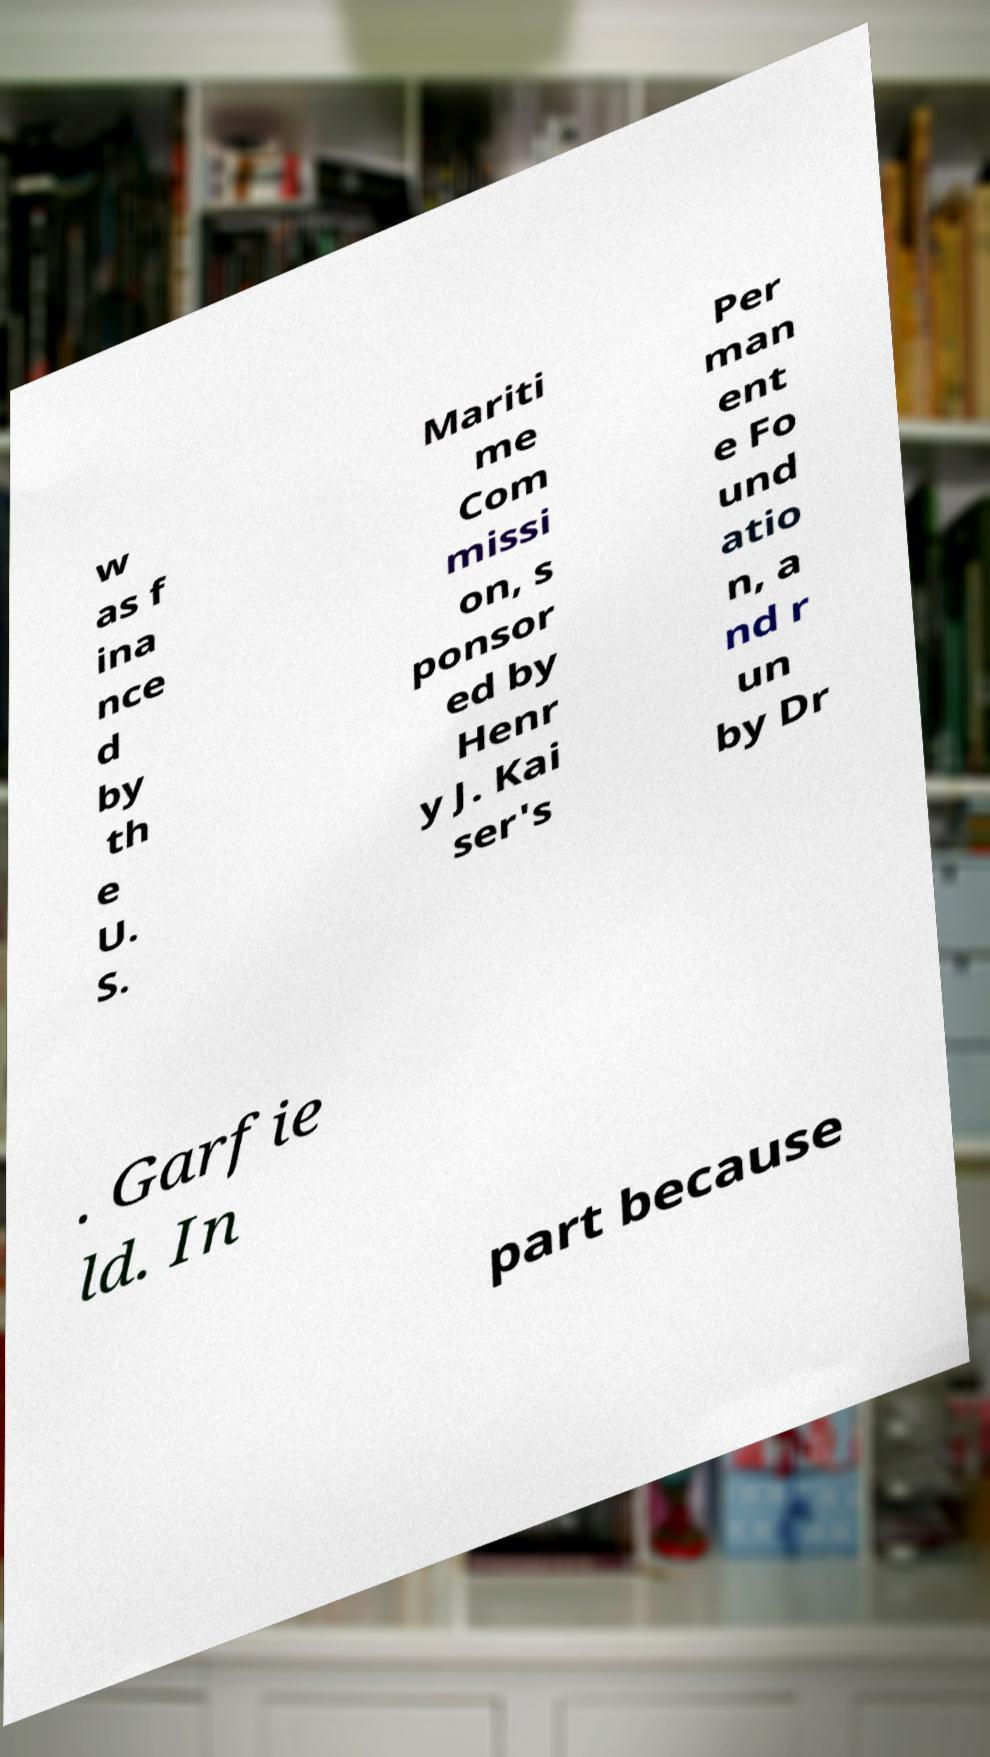Can you read and provide the text displayed in the image?This photo seems to have some interesting text. Can you extract and type it out for me? w as f ina nce d by th e U. S. Mariti me Com missi on, s ponsor ed by Henr y J. Kai ser's Per man ent e Fo und atio n, a nd r un by Dr . Garfie ld. In part because 